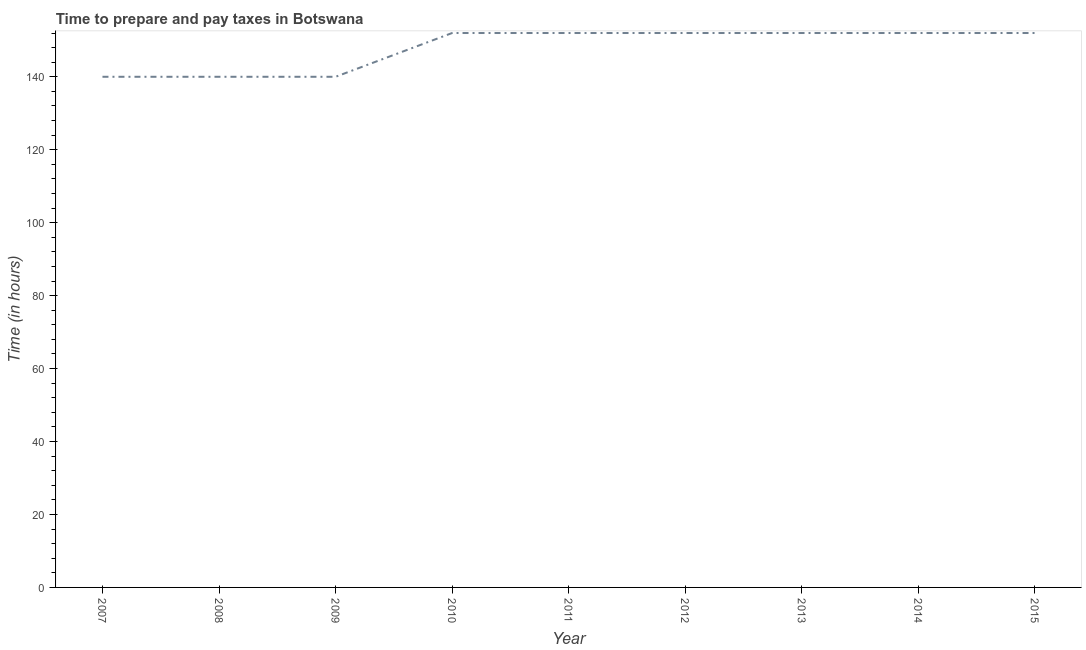What is the time to prepare and pay taxes in 2011?
Keep it short and to the point. 152. Across all years, what is the maximum time to prepare and pay taxes?
Your answer should be compact. 152. Across all years, what is the minimum time to prepare and pay taxes?
Give a very brief answer. 140. In which year was the time to prepare and pay taxes minimum?
Your answer should be very brief. 2007. What is the sum of the time to prepare and pay taxes?
Give a very brief answer. 1332. What is the average time to prepare and pay taxes per year?
Offer a terse response. 148. What is the median time to prepare and pay taxes?
Your answer should be compact. 152. In how many years, is the time to prepare and pay taxes greater than 96 hours?
Give a very brief answer. 9. Is the time to prepare and pay taxes in 2012 less than that in 2013?
Give a very brief answer. No. Is the difference between the time to prepare and pay taxes in 2008 and 2011 greater than the difference between any two years?
Your answer should be very brief. Yes. What is the difference between the highest and the second highest time to prepare and pay taxes?
Provide a succinct answer. 0. Is the sum of the time to prepare and pay taxes in 2010 and 2014 greater than the maximum time to prepare and pay taxes across all years?
Provide a short and direct response. Yes. What is the difference between the highest and the lowest time to prepare and pay taxes?
Give a very brief answer. 12. Does the time to prepare and pay taxes monotonically increase over the years?
Provide a short and direct response. No. How many years are there in the graph?
Offer a very short reply. 9. What is the title of the graph?
Offer a terse response. Time to prepare and pay taxes in Botswana. What is the label or title of the X-axis?
Your answer should be compact. Year. What is the label or title of the Y-axis?
Provide a short and direct response. Time (in hours). What is the Time (in hours) of 2007?
Offer a terse response. 140. What is the Time (in hours) of 2008?
Your response must be concise. 140. What is the Time (in hours) in 2009?
Ensure brevity in your answer.  140. What is the Time (in hours) in 2010?
Offer a very short reply. 152. What is the Time (in hours) in 2011?
Offer a very short reply. 152. What is the Time (in hours) of 2012?
Offer a terse response. 152. What is the Time (in hours) of 2013?
Your response must be concise. 152. What is the Time (in hours) in 2014?
Ensure brevity in your answer.  152. What is the Time (in hours) of 2015?
Provide a succinct answer. 152. What is the difference between the Time (in hours) in 2007 and 2010?
Offer a very short reply. -12. What is the difference between the Time (in hours) in 2007 and 2014?
Give a very brief answer. -12. What is the difference between the Time (in hours) in 2008 and 2010?
Your response must be concise. -12. What is the difference between the Time (in hours) in 2008 and 2011?
Provide a succinct answer. -12. What is the difference between the Time (in hours) in 2008 and 2013?
Provide a short and direct response. -12. What is the difference between the Time (in hours) in 2008 and 2015?
Provide a short and direct response. -12. What is the difference between the Time (in hours) in 2009 and 2012?
Offer a very short reply. -12. What is the difference between the Time (in hours) in 2009 and 2014?
Make the answer very short. -12. What is the difference between the Time (in hours) in 2009 and 2015?
Give a very brief answer. -12. What is the difference between the Time (in hours) in 2010 and 2014?
Your answer should be very brief. 0. What is the difference between the Time (in hours) in 2010 and 2015?
Offer a very short reply. 0. What is the difference between the Time (in hours) in 2011 and 2013?
Keep it short and to the point. 0. What is the difference between the Time (in hours) in 2011 and 2014?
Ensure brevity in your answer.  0. What is the difference between the Time (in hours) in 2011 and 2015?
Keep it short and to the point. 0. What is the difference between the Time (in hours) in 2012 and 2014?
Your answer should be compact. 0. What is the difference between the Time (in hours) in 2014 and 2015?
Offer a very short reply. 0. What is the ratio of the Time (in hours) in 2007 to that in 2009?
Provide a short and direct response. 1. What is the ratio of the Time (in hours) in 2007 to that in 2010?
Ensure brevity in your answer.  0.92. What is the ratio of the Time (in hours) in 2007 to that in 2011?
Your answer should be compact. 0.92. What is the ratio of the Time (in hours) in 2007 to that in 2012?
Ensure brevity in your answer.  0.92. What is the ratio of the Time (in hours) in 2007 to that in 2013?
Your response must be concise. 0.92. What is the ratio of the Time (in hours) in 2007 to that in 2014?
Your answer should be very brief. 0.92. What is the ratio of the Time (in hours) in 2007 to that in 2015?
Your answer should be compact. 0.92. What is the ratio of the Time (in hours) in 2008 to that in 2009?
Offer a terse response. 1. What is the ratio of the Time (in hours) in 2008 to that in 2010?
Offer a terse response. 0.92. What is the ratio of the Time (in hours) in 2008 to that in 2011?
Provide a short and direct response. 0.92. What is the ratio of the Time (in hours) in 2008 to that in 2012?
Ensure brevity in your answer.  0.92. What is the ratio of the Time (in hours) in 2008 to that in 2013?
Keep it short and to the point. 0.92. What is the ratio of the Time (in hours) in 2008 to that in 2014?
Give a very brief answer. 0.92. What is the ratio of the Time (in hours) in 2008 to that in 2015?
Your answer should be very brief. 0.92. What is the ratio of the Time (in hours) in 2009 to that in 2010?
Your answer should be very brief. 0.92. What is the ratio of the Time (in hours) in 2009 to that in 2011?
Your answer should be compact. 0.92. What is the ratio of the Time (in hours) in 2009 to that in 2012?
Offer a very short reply. 0.92. What is the ratio of the Time (in hours) in 2009 to that in 2013?
Give a very brief answer. 0.92. What is the ratio of the Time (in hours) in 2009 to that in 2014?
Offer a very short reply. 0.92. What is the ratio of the Time (in hours) in 2009 to that in 2015?
Keep it short and to the point. 0.92. What is the ratio of the Time (in hours) in 2010 to that in 2011?
Give a very brief answer. 1. What is the ratio of the Time (in hours) in 2010 to that in 2013?
Provide a succinct answer. 1. What is the ratio of the Time (in hours) in 2010 to that in 2015?
Your answer should be very brief. 1. What is the ratio of the Time (in hours) in 2011 to that in 2013?
Ensure brevity in your answer.  1. What is the ratio of the Time (in hours) in 2011 to that in 2014?
Provide a short and direct response. 1. What is the ratio of the Time (in hours) in 2011 to that in 2015?
Your answer should be very brief. 1. What is the ratio of the Time (in hours) in 2012 to that in 2014?
Offer a very short reply. 1. What is the ratio of the Time (in hours) in 2012 to that in 2015?
Your answer should be compact. 1. What is the ratio of the Time (in hours) in 2013 to that in 2014?
Give a very brief answer. 1. What is the ratio of the Time (in hours) in 2013 to that in 2015?
Offer a terse response. 1. What is the ratio of the Time (in hours) in 2014 to that in 2015?
Offer a terse response. 1. 